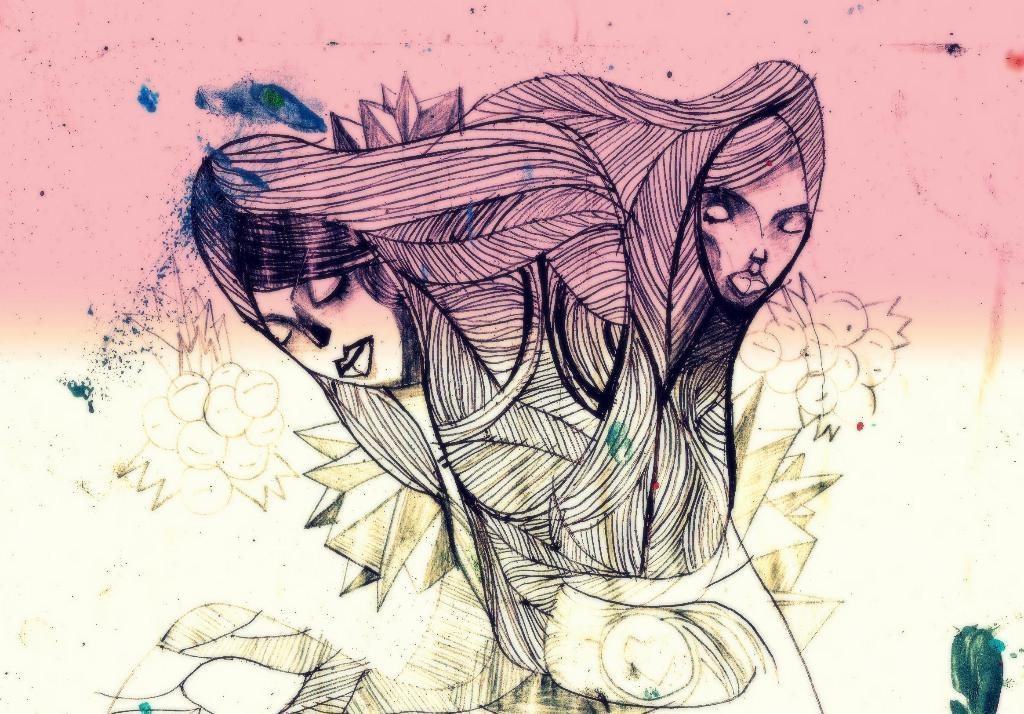What is the main subject of the image? The main subject of the image is a painting. What is depicted in the painting? The painting has two faces. What colors are used on the surface of the painting? The surface of the painting is pink and cream in color. Can you see any alley, salt, or waves in the image? No, there are no alley, salt, or waves present in the image; it features a painting with two faces. 